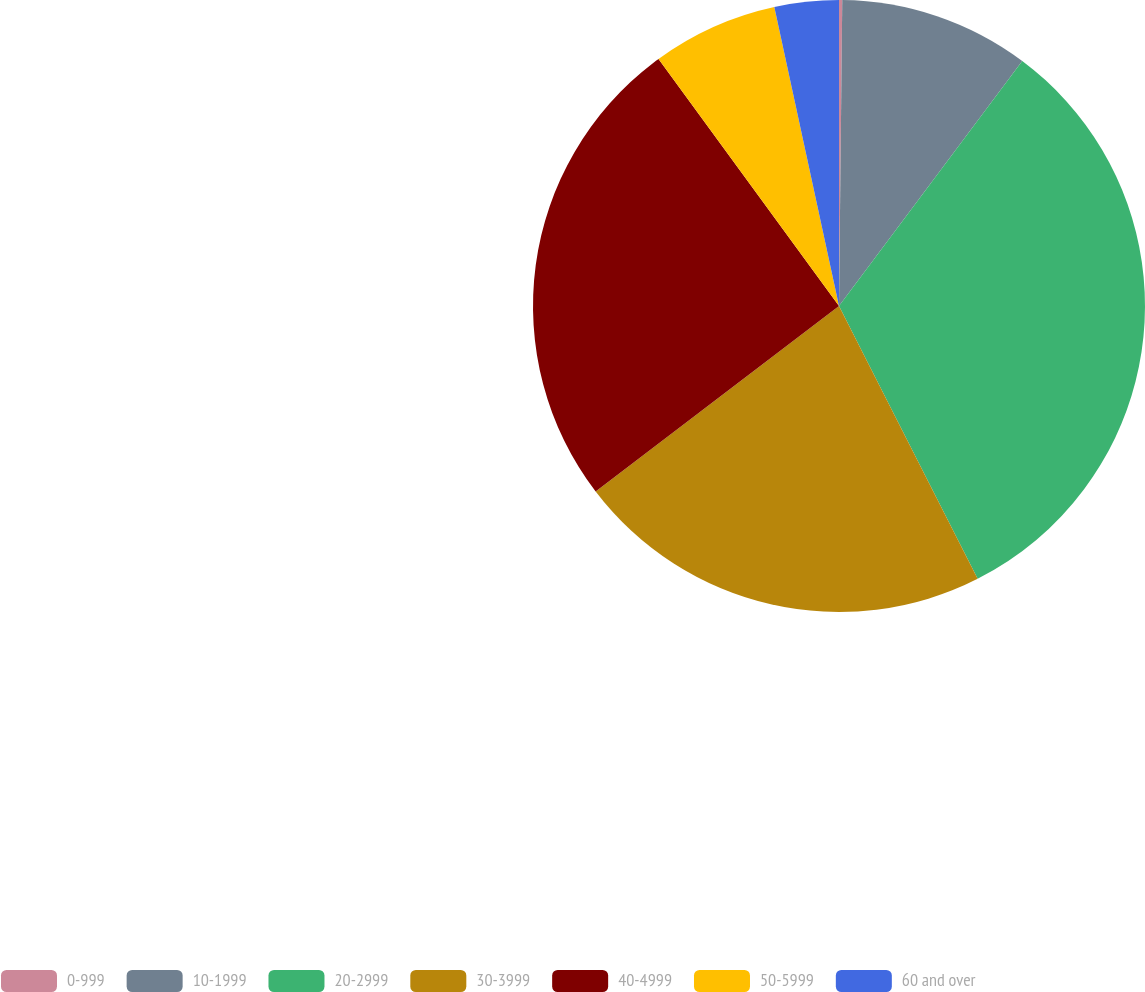Convert chart to OTSL. <chart><loc_0><loc_0><loc_500><loc_500><pie_chart><fcel>0-999<fcel>10-1999<fcel>20-2999<fcel>30-3999<fcel>40-4999<fcel>50-5999<fcel>60 and over<nl><fcel>0.17%<fcel>10.05%<fcel>32.3%<fcel>22.12%<fcel>25.33%<fcel>6.65%<fcel>3.39%<nl></chart> 